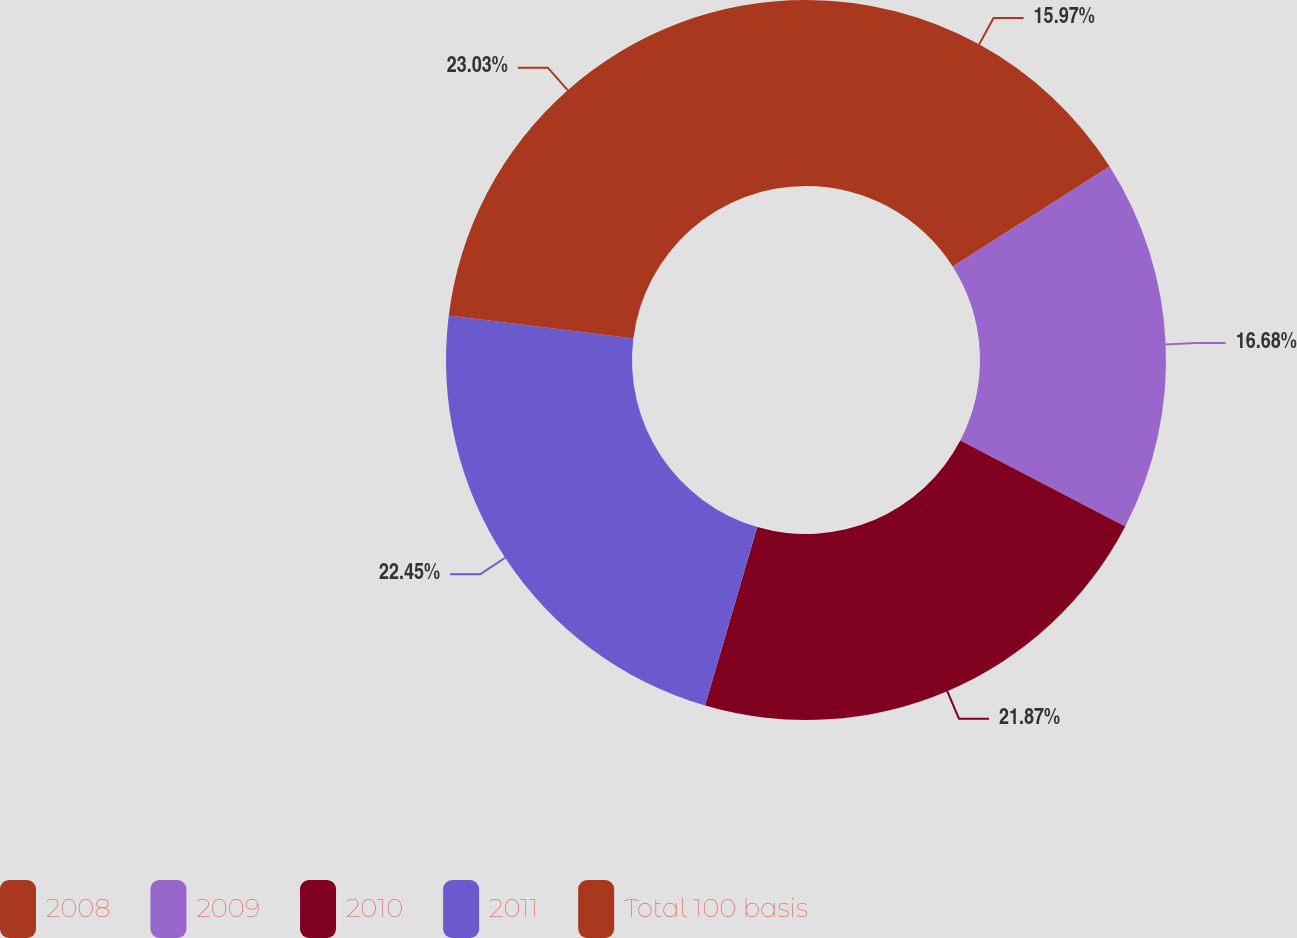<chart> <loc_0><loc_0><loc_500><loc_500><pie_chart><fcel>2008<fcel>2009<fcel>2010<fcel>2011<fcel>Total 100 basis<nl><fcel>15.97%<fcel>16.68%<fcel>21.87%<fcel>22.45%<fcel>23.03%<nl></chart> 